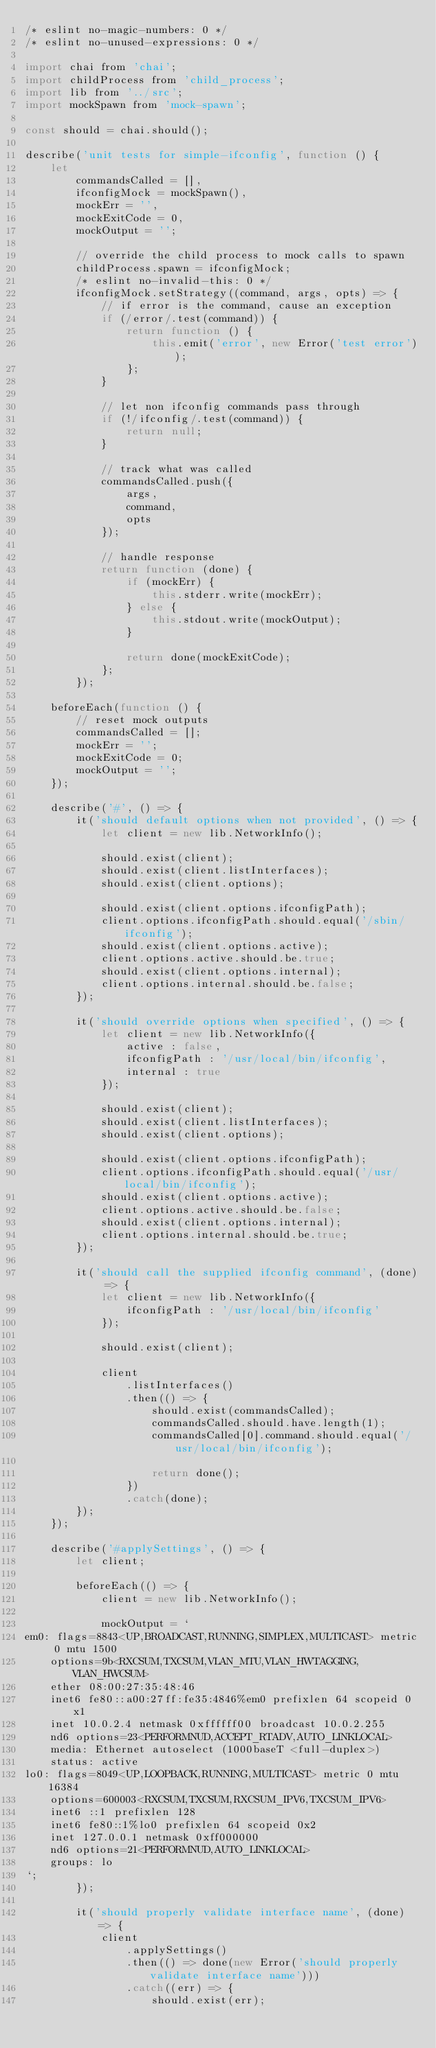<code> <loc_0><loc_0><loc_500><loc_500><_JavaScript_>/* eslint no-magic-numbers: 0 */
/* eslint no-unused-expressions: 0 */

import chai from 'chai';
import childProcess from 'child_process';
import lib from '../src';
import mockSpawn from 'mock-spawn';

const should = chai.should();

describe('unit tests for simple-ifconfig', function () {
	let
		commandsCalled = [],
		ifconfigMock = mockSpawn(),
		mockErr = '',
		mockExitCode = 0,
		mockOutput = '';

		// override the child process to mock calls to spawn
		childProcess.spawn = ifconfigMock;
		/* eslint no-invalid-this: 0 */
		ifconfigMock.setStrategy((command, args, opts) => {
			// if error is the command, cause an exception
			if (/error/.test(command)) {
				return function () {
					this.emit('error', new Error('test error'));
				};
			}

			// let non ifconfig commands pass through
			if (!/ifconfig/.test(command)) {
				return null;
			}

			// track what was called
			commandsCalled.push({
				args,
				command,
				opts
			});

			// handle response
			return function (done) {
				if (mockErr) {
					this.stderr.write(mockErr);
				} else {
					this.stdout.write(mockOutput);
				}

				return done(mockExitCode);
			};
		});

	beforeEach(function () {
		// reset mock outputs
		commandsCalled = [];
		mockErr = '';
		mockExitCode = 0;
		mockOutput = '';
	});

	describe('#', () => {
		it('should default options when not provided', () => {
			let client = new lib.NetworkInfo();

			should.exist(client);
			should.exist(client.listInterfaces);
			should.exist(client.options);

			should.exist(client.options.ifconfigPath);
			client.options.ifconfigPath.should.equal('/sbin/ifconfig');
			should.exist(client.options.active);
			client.options.active.should.be.true;
			should.exist(client.options.internal);
			client.options.internal.should.be.false;
		});

		it('should override options when specified', () => {
			let client = new lib.NetworkInfo({
				active : false,
				ifconfigPath : '/usr/local/bin/ifconfig',
				internal : true
			});

			should.exist(client);
			should.exist(client.listInterfaces);
			should.exist(client.options);

			should.exist(client.options.ifconfigPath);
			client.options.ifconfigPath.should.equal('/usr/local/bin/ifconfig');
			should.exist(client.options.active);
			client.options.active.should.be.false;
			should.exist(client.options.internal);
			client.options.internal.should.be.true;
		});

		it('should call the supplied ifconfig command', (done) => {
			let client = new lib.NetworkInfo({
				ifconfigPath : '/usr/local/bin/ifconfig'
			});

			should.exist(client);

			client
				.listInterfaces()
				.then(() => {
					should.exist(commandsCalled);
					commandsCalled.should.have.length(1);
					commandsCalled[0].command.should.equal('/usr/local/bin/ifconfig');

					return done();
				})
				.catch(done);
		});
	});

	describe('#applySettings', () => {
		let client;

		beforeEach(() => {
			client = new lib.NetworkInfo();

			mockOutput = `
em0: flags=8843<UP,BROADCAST,RUNNING,SIMPLEX,MULTICAST> metric 0 mtu 1500
	options=9b<RXCSUM,TXCSUM,VLAN_MTU,VLAN_HWTAGGING,VLAN_HWCSUM>
	ether 08:00:27:35:48:46
	inet6 fe80::a00:27ff:fe35:4846%em0 prefixlen 64 scopeid 0x1
	inet 10.0.2.4 netmask 0xffffff00 broadcast 10.0.2.255
	nd6 options=23<PERFORMNUD,ACCEPT_RTADV,AUTO_LINKLOCAL>
	media: Ethernet autoselect (1000baseT <full-duplex>)
	status: active
lo0: flags=8049<UP,LOOPBACK,RUNNING,MULTICAST> metric 0 mtu 16384
	options=600003<RXCSUM,TXCSUM,RXCSUM_IPV6,TXCSUM_IPV6>
	inet6 ::1 prefixlen 128
	inet6 fe80::1%lo0 prefixlen 64 scopeid 0x2
	inet 127.0.0.1 netmask 0xff000000
	nd6 options=21<PERFORMNUD,AUTO_LINKLOCAL>
	groups: lo
`;
		});

		it('should properly validate interface name', (done) => {
			client
				.applySettings()
				.then(() => done(new Error('should properly validate interface name')))
				.catch((err) => {
					should.exist(err);</code> 